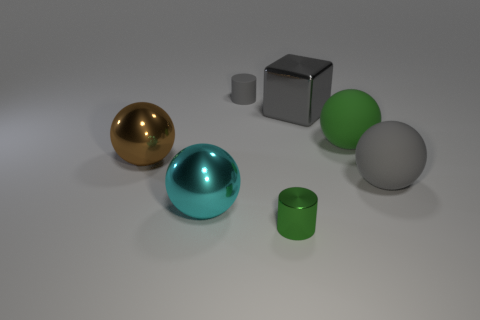Subtract all green spheres. How many spheres are left? 3 Subtract all gray cylinders. How many cylinders are left? 1 Subtract 1 spheres. How many spheres are left? 3 Add 3 large gray spheres. How many objects exist? 10 Subtract all blocks. How many objects are left? 6 Subtract all purple cylinders. Subtract all purple cubes. How many cylinders are left? 2 Subtract all big gray blocks. Subtract all gray shiny objects. How many objects are left? 5 Add 4 large green rubber things. How many large green rubber things are left? 5 Add 5 brown metallic balls. How many brown metallic balls exist? 6 Subtract 1 green cylinders. How many objects are left? 6 